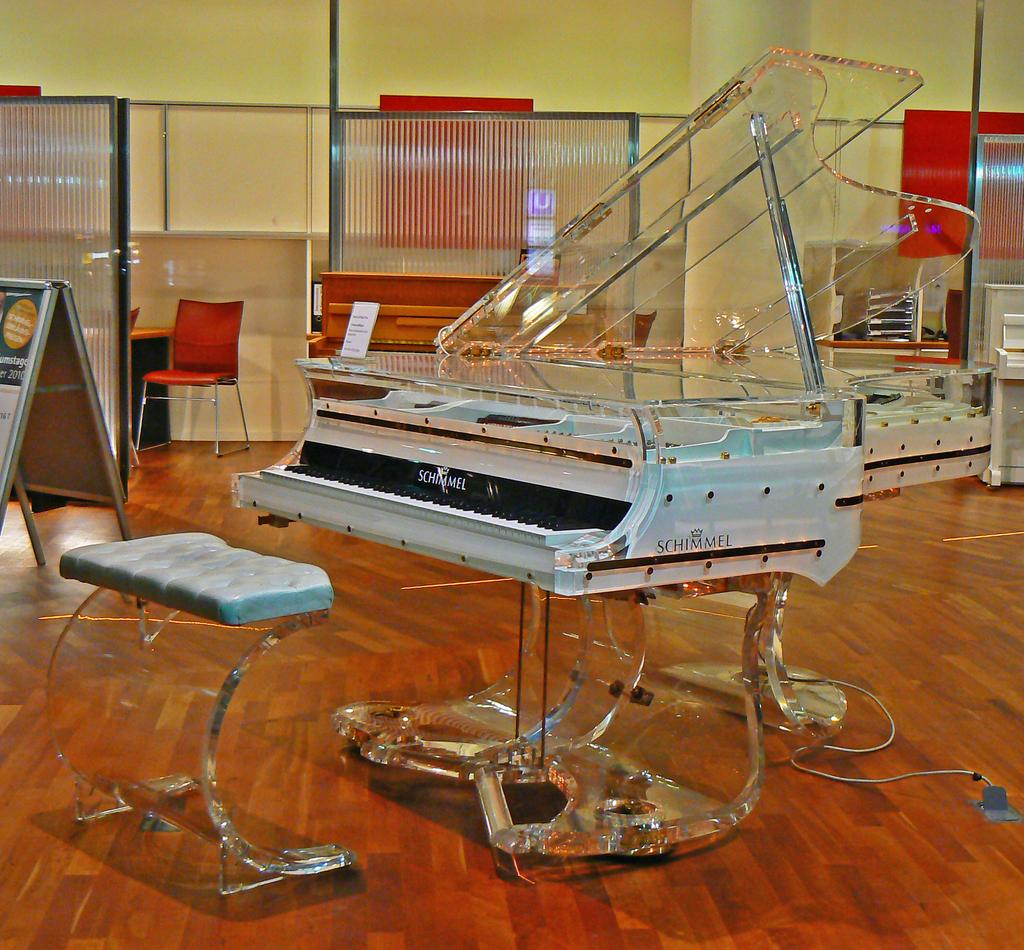What musical instrument is present in the image? There is a piano in the image. Is there any furniture near the piano for someone to sit on? Yes, there is a chair for sitting near the piano. Are there any other chairs visible in the image? Yes, there are additional chairs visible in the image. Are there any other pianos visible in the image? Yes, there are other pianos visible in the image. What type of science experiment is being conducted on the kitty in the image? There is no kitty or science experiment present in the image. What color is the cub sitting on the piano in the image? There is no cub present in the image. 